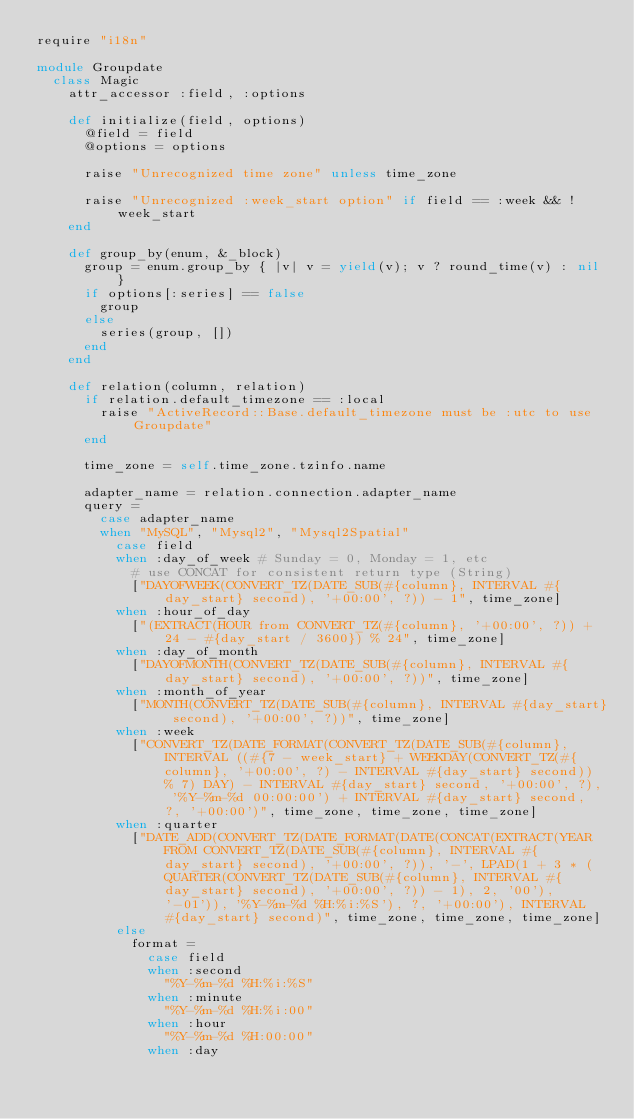<code> <loc_0><loc_0><loc_500><loc_500><_Ruby_>require "i18n"

module Groupdate
  class Magic
    attr_accessor :field, :options

    def initialize(field, options)
      @field = field
      @options = options

      raise "Unrecognized time zone" unless time_zone

      raise "Unrecognized :week_start option" if field == :week && !week_start
    end

    def group_by(enum, &_block)
      group = enum.group_by { |v| v = yield(v); v ? round_time(v) : nil }
      if options[:series] == false
        group
      else
        series(group, [])
      end
    end

    def relation(column, relation)
      if relation.default_timezone == :local
        raise "ActiveRecord::Base.default_timezone must be :utc to use Groupdate"
      end

      time_zone = self.time_zone.tzinfo.name

      adapter_name = relation.connection.adapter_name
      query =
        case adapter_name
        when "MySQL", "Mysql2", "Mysql2Spatial"
          case field
          when :day_of_week # Sunday = 0, Monday = 1, etc
            # use CONCAT for consistent return type (String)
            ["DAYOFWEEK(CONVERT_TZ(DATE_SUB(#{column}, INTERVAL #{day_start} second), '+00:00', ?)) - 1", time_zone]
          when :hour_of_day
            ["(EXTRACT(HOUR from CONVERT_TZ(#{column}, '+00:00', ?)) + 24 - #{day_start / 3600}) % 24", time_zone]
          when :day_of_month
            ["DAYOFMONTH(CONVERT_TZ(DATE_SUB(#{column}, INTERVAL #{day_start} second), '+00:00', ?))", time_zone]
          when :month_of_year
            ["MONTH(CONVERT_TZ(DATE_SUB(#{column}, INTERVAL #{day_start} second), '+00:00', ?))", time_zone]
          when :week
            ["CONVERT_TZ(DATE_FORMAT(CONVERT_TZ(DATE_SUB(#{column}, INTERVAL ((#{7 - week_start} + WEEKDAY(CONVERT_TZ(#{column}, '+00:00', ?) - INTERVAL #{day_start} second)) % 7) DAY) - INTERVAL #{day_start} second, '+00:00', ?), '%Y-%m-%d 00:00:00') + INTERVAL #{day_start} second, ?, '+00:00')", time_zone, time_zone, time_zone]
          when :quarter
            ["DATE_ADD(CONVERT_TZ(DATE_FORMAT(DATE(CONCAT(EXTRACT(YEAR FROM CONVERT_TZ(DATE_SUB(#{column}, INTERVAL #{day_start} second), '+00:00', ?)), '-', LPAD(1 + 3 * (QUARTER(CONVERT_TZ(DATE_SUB(#{column}, INTERVAL #{day_start} second), '+00:00', ?)) - 1), 2, '00'), '-01')), '%Y-%m-%d %H:%i:%S'), ?, '+00:00'), INTERVAL #{day_start} second)", time_zone, time_zone, time_zone]
          else
            format =
              case field
              when :second
                "%Y-%m-%d %H:%i:%S"
              when :minute
                "%Y-%m-%d %H:%i:00"
              when :hour
                "%Y-%m-%d %H:00:00"
              when :day</code> 